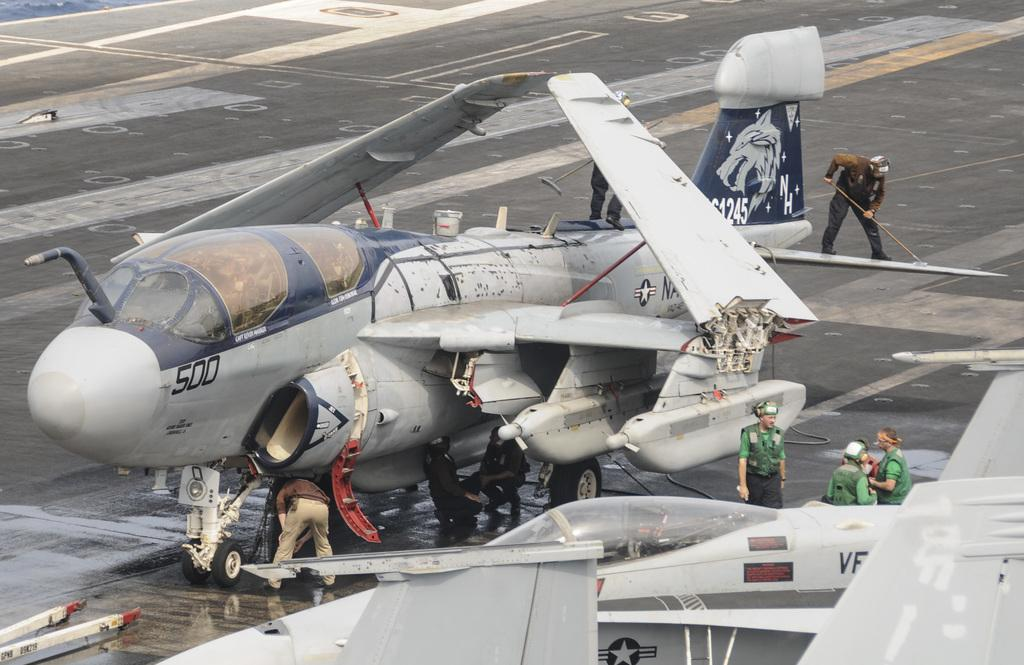<image>
Give a short and clear explanation of the subsequent image. A plane has the number 500 on the front and NH painted on the tail. 